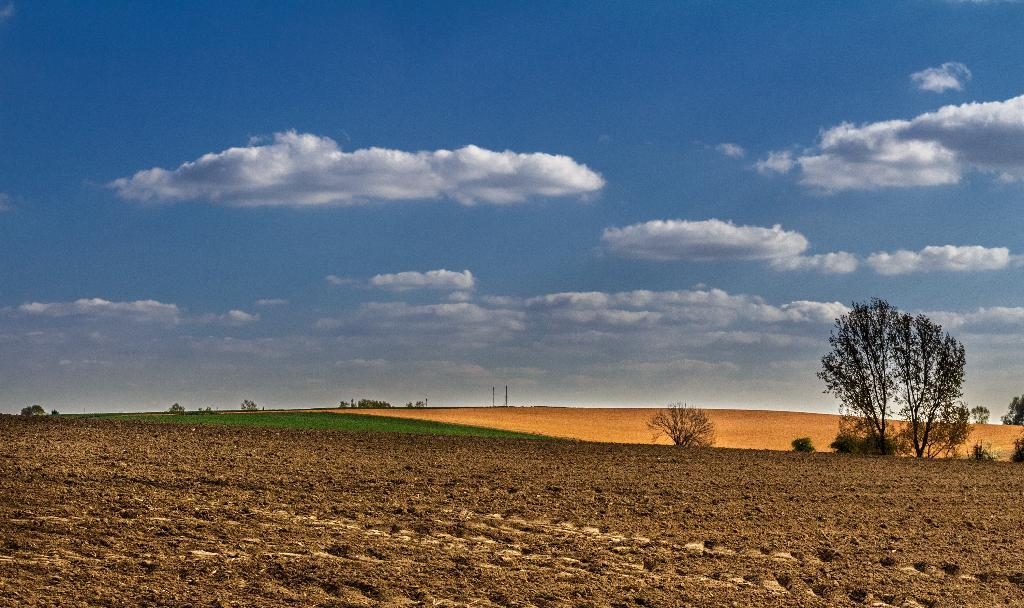What type of vegetation can be seen in the image? There are trees in the image. What type of terrain is visible in the image? There is land visible in the image. What type of ground cover is present in the image? There is grass in the image. What is visible at the top of the image? The sky is visible at the top of the image. Is there a celery field visible in the image? There is no celery field present in the image. Can you see a bridge crossing the land in the image? There is no bridge visible in the image. 